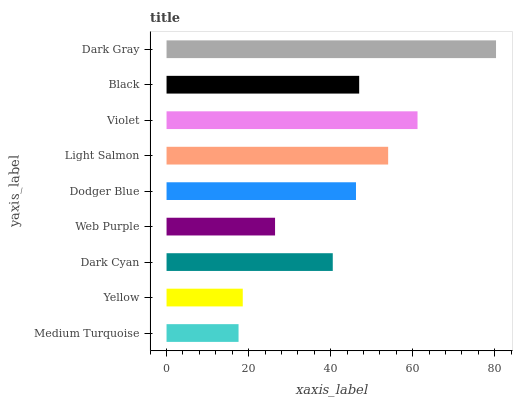Is Medium Turquoise the minimum?
Answer yes or no. Yes. Is Dark Gray the maximum?
Answer yes or no. Yes. Is Yellow the minimum?
Answer yes or no. No. Is Yellow the maximum?
Answer yes or no. No. Is Yellow greater than Medium Turquoise?
Answer yes or no. Yes. Is Medium Turquoise less than Yellow?
Answer yes or no. Yes. Is Medium Turquoise greater than Yellow?
Answer yes or no. No. Is Yellow less than Medium Turquoise?
Answer yes or no. No. Is Dodger Blue the high median?
Answer yes or no. Yes. Is Dodger Blue the low median?
Answer yes or no. Yes. Is Web Purple the high median?
Answer yes or no. No. Is Dark Gray the low median?
Answer yes or no. No. 